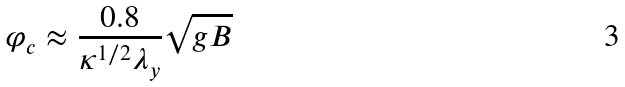Convert formula to latex. <formula><loc_0><loc_0><loc_500><loc_500>\varphi _ { c } \approx \frac { 0 . 8 } { \kappa ^ { 1 / 2 } \lambda _ { y } } \sqrt { g B }</formula> 